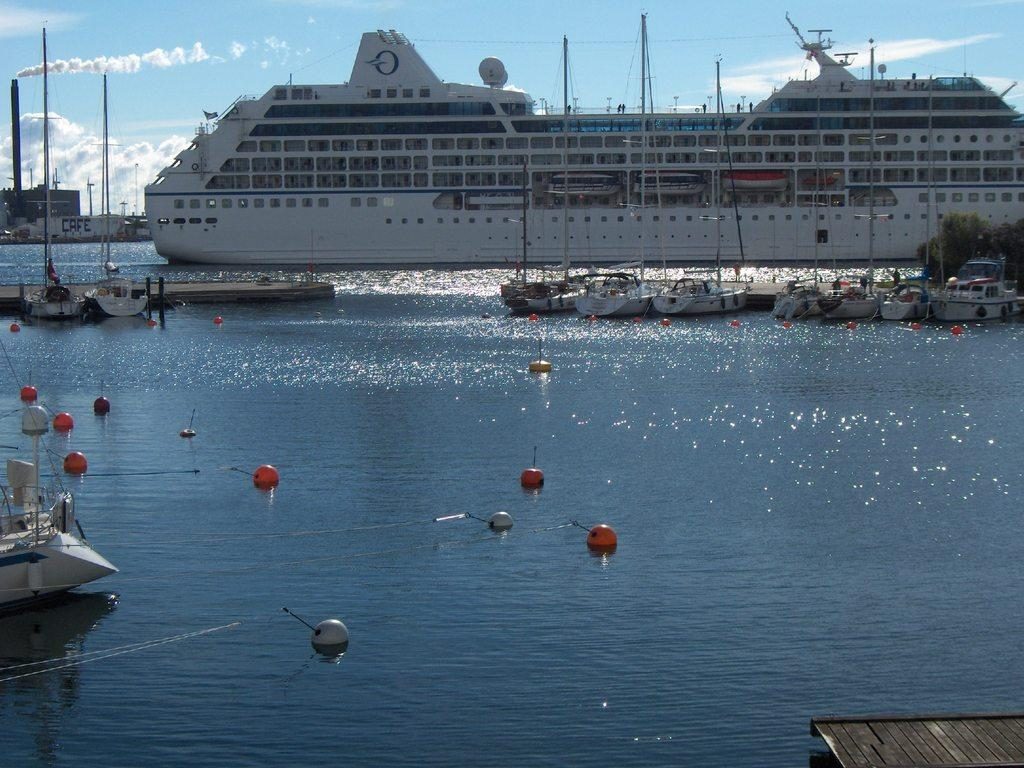What is in the water in the image? There are balls in the water. What type of watercraft can be seen in the image? There are boats and a big ship in the image. What is visible at the top of the image? The sky is visible at the top of the image. What type of furniture can be seen in the image? There is no furniture present in the image; it features balls in the water, boats, a big ship, and the sky. How many spades are being used to play in the water? There is no indication of any spades being used in the image, as it features balls in the water and various watercraft. 